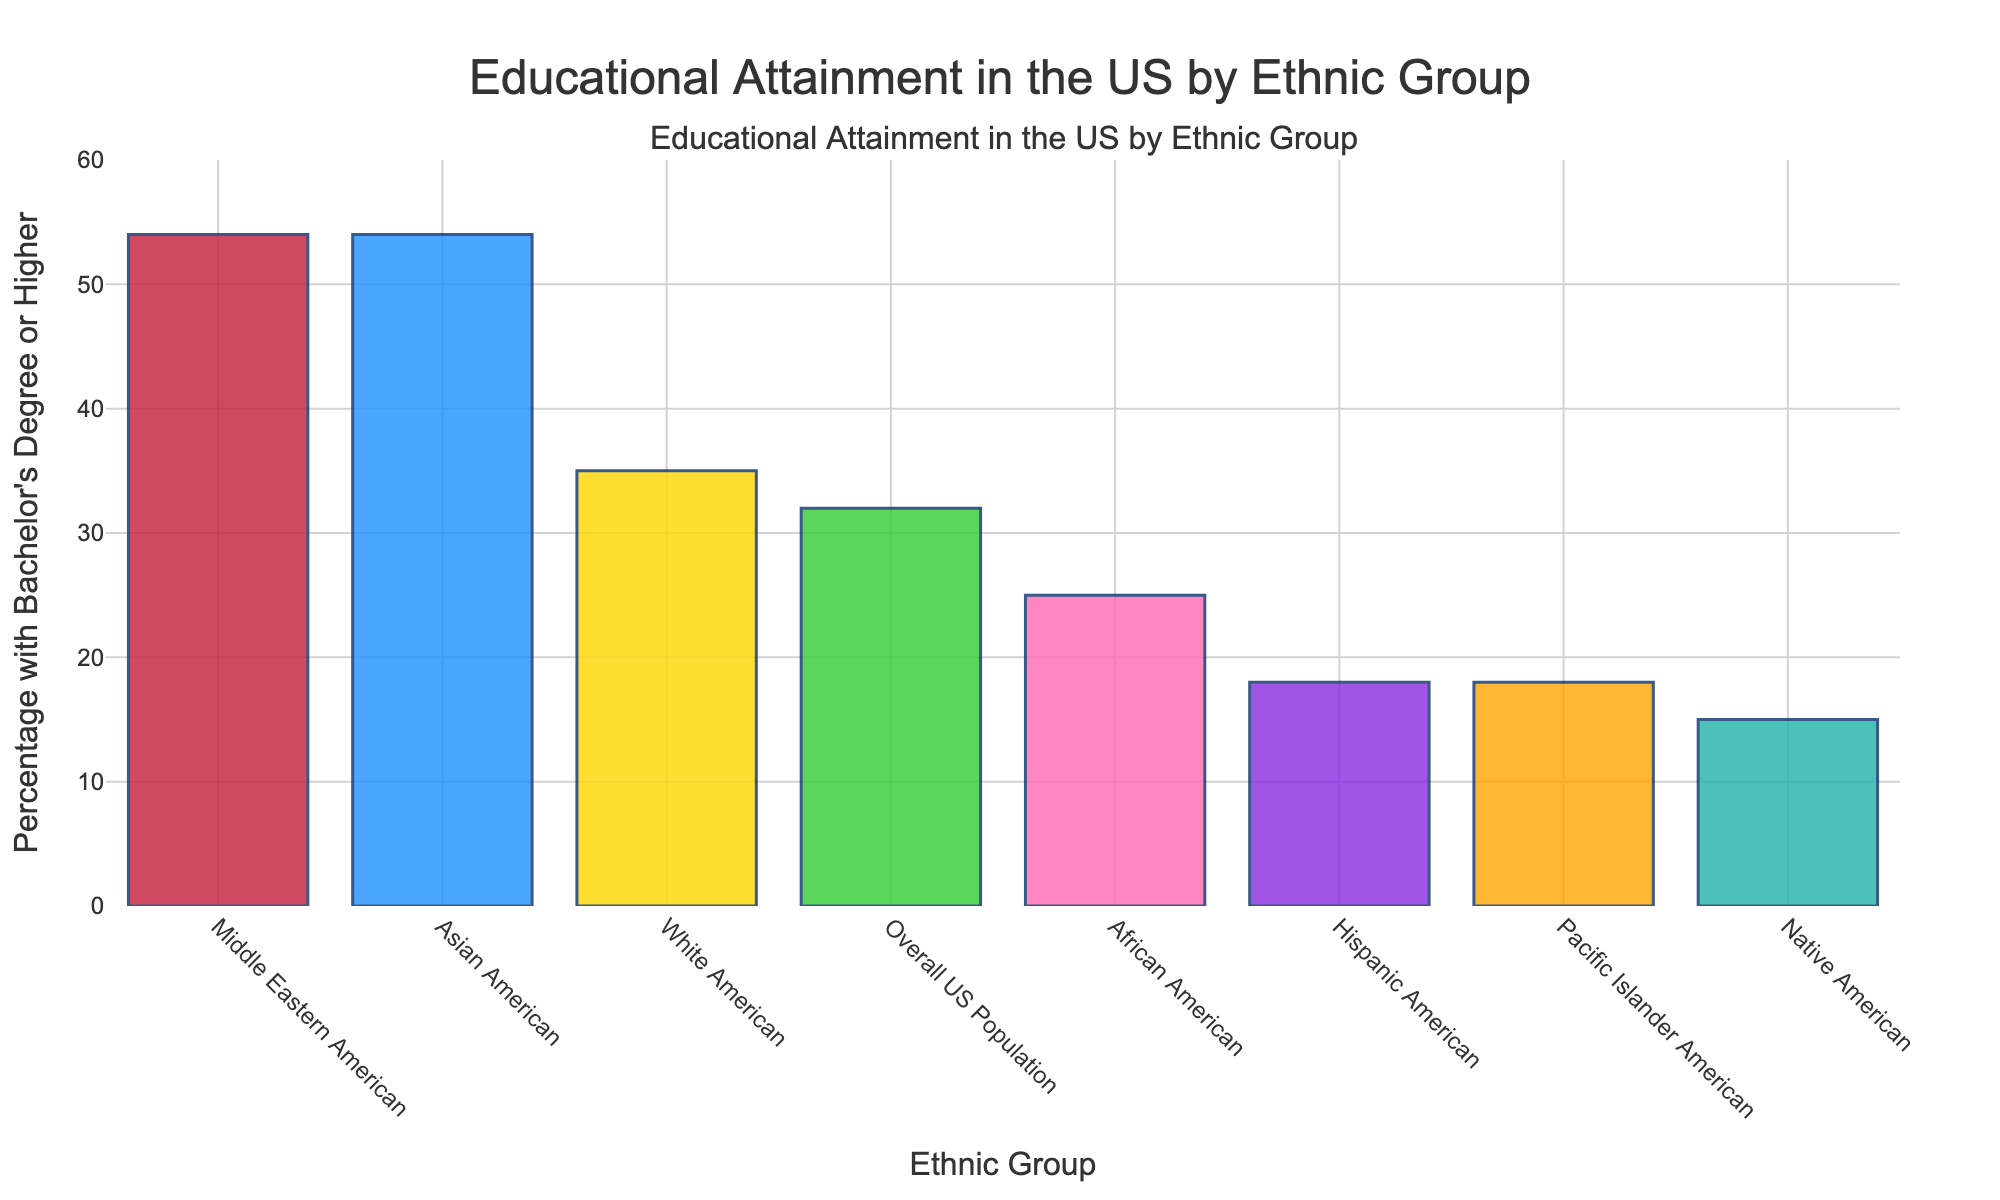Which ethnic group has the highest percentage of individuals with a Bachelor's Degree or higher? By examining the heights of the bars in the figure, we see that Middle Eastern Americans and Asian Americans both have the highest bar, indicating the highest percentage of individuals with a Bachelor's Degree or higher. The percentage is 54% for both groups.
Answer: Middle Eastern Americans and Asian Americans How does the educational attainment of Hispanic Americans compare to that of White Americans? To compare, look at the two respective bars. The bar for Hispanic Americans is much shorter than the bar for White Americans, indicating that the educational attainment is lower. Specifically, 18% of Hispanic Americans have a Bachelor's Degree or higher, whereas 35% of White Americans do.
Answer: Hispanic Americans are lower What is the average percentage of individuals with a Bachelor's Degree or higher for all ethnic groups shown? First, add the percentages of all groups: 54 + 54 + 35 + 25 + 18 + 15 + 18 + 32 = 251. Then, divide by the number of groups, which is 8: 251 / 8 = 31.375.
Answer: 31.375 How much higher is the percentage of Middle Eastern Americans with Bachelor's Degrees compared to the overall US population? Look at the difference between the percentage for Middle Eastern Americans (54%) and the overall US population (32%). Subtract 32 from 54: 54 - 32 = 22.
Answer: 22% Which ethnic group has the lowest percentage of individuals with a Bachelor's Degree or higher? By examining the heights of the bars in the figure, the Native American group has the lowest bar, indicating the lowest percentage of individuals with a Bachelor's Degree or higher, which is 15%.
Answer: Native Americans What is the sum of the percentages of individuals with a Bachelor's Degree or higher for African Americans and Pacific Islander Americans? To find the sum, add the percentages for the two groups: 25% (African Americans) + 18% (Pacific Islander Americans) = 43%.
Answer: 43% Is the percentage of individuals with a Bachelor's Degree or higher for Asian Americans greater than, less than, or equal to that of Middle Eastern Americans? By examining the heights of the bars in the figure for these two groups, we see that they are equal. Both groups have a percentage of 54%.
Answer: Equal Which groups have a higher percentage of Bachelor's Degree or higher compared to the overall US population? Compare the bars of each group to the overall US population bar, which is 32%. The groups with higher percentages are Middle Eastern Americans (54%), Asian Americans (54%), and White Americans (35%).
Answer: Middle Eastern Americans, Asian Americans, and White Americans 